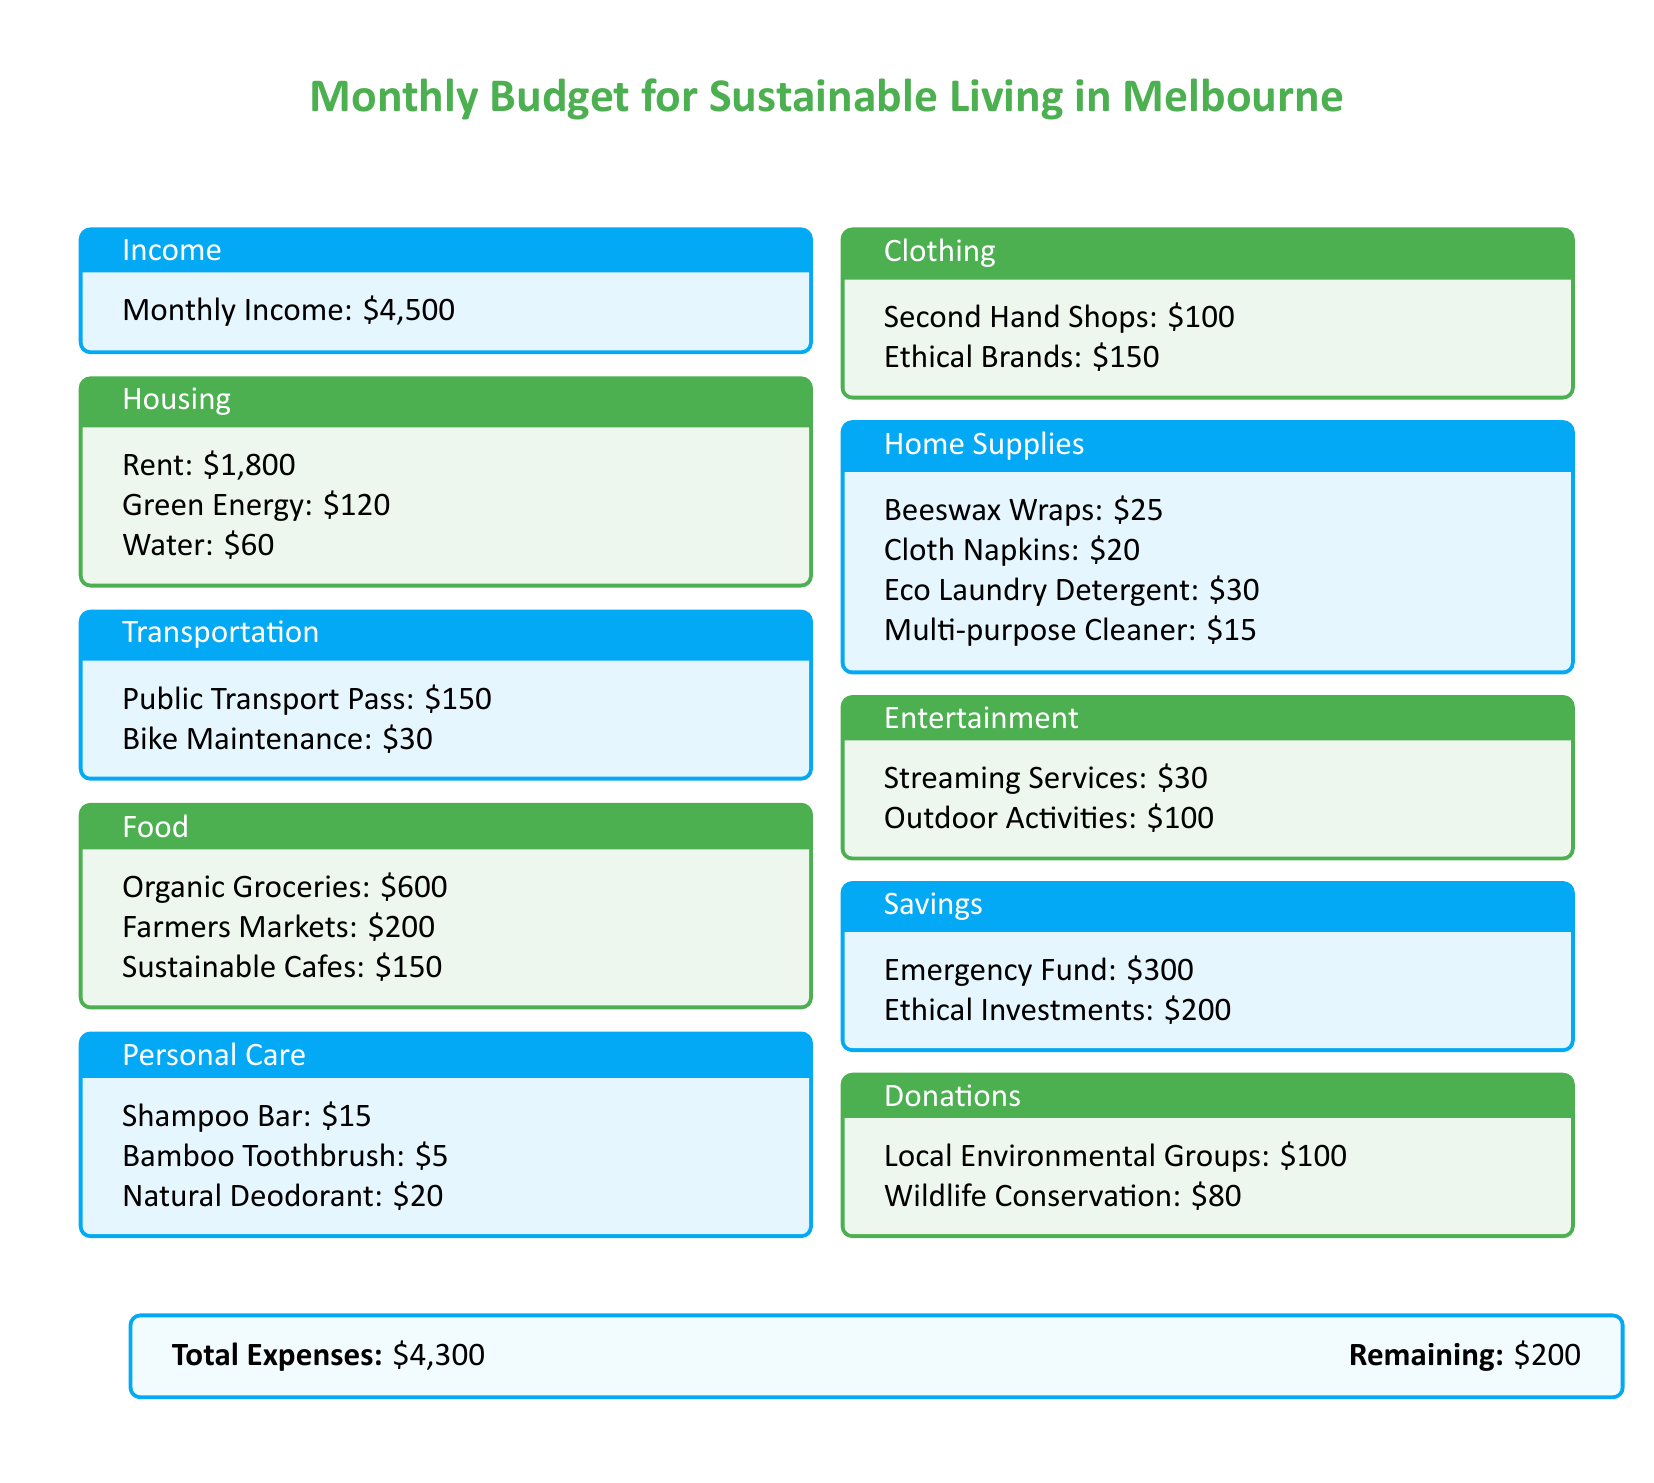What is the monthly income? The monthly income is stated in the income section of the document.
Answer: $4,500 How much is spent on organic groceries? The amount spent on organic groceries is listed in the food section.
Answer: $600 What is the cost of the public transport pass? The cost is detailed in the transportation box.
Answer: $150 What are the total expenses? The total expenses are at the bottom of the document and include all spending.
Answer: $4,300 What is the remaining amount after expenses? The remaining amount is shown along with the total expenses.
Answer: $200 How much is allocated to ethical investments? The allocation for ethical investments is found in the savings box.
Answer: $200 What is the budget for donations to local environmental groups? The budget is specified in the donations section.
Answer: $100 How much is allocated for sustainable cafes? The amount for sustainable cafes is stated in the food section.
Answer: $150 What is the total cost for personal care items? The total cost for personal care can be calculated by adding all listed expenses in that section.
Answer: $40 